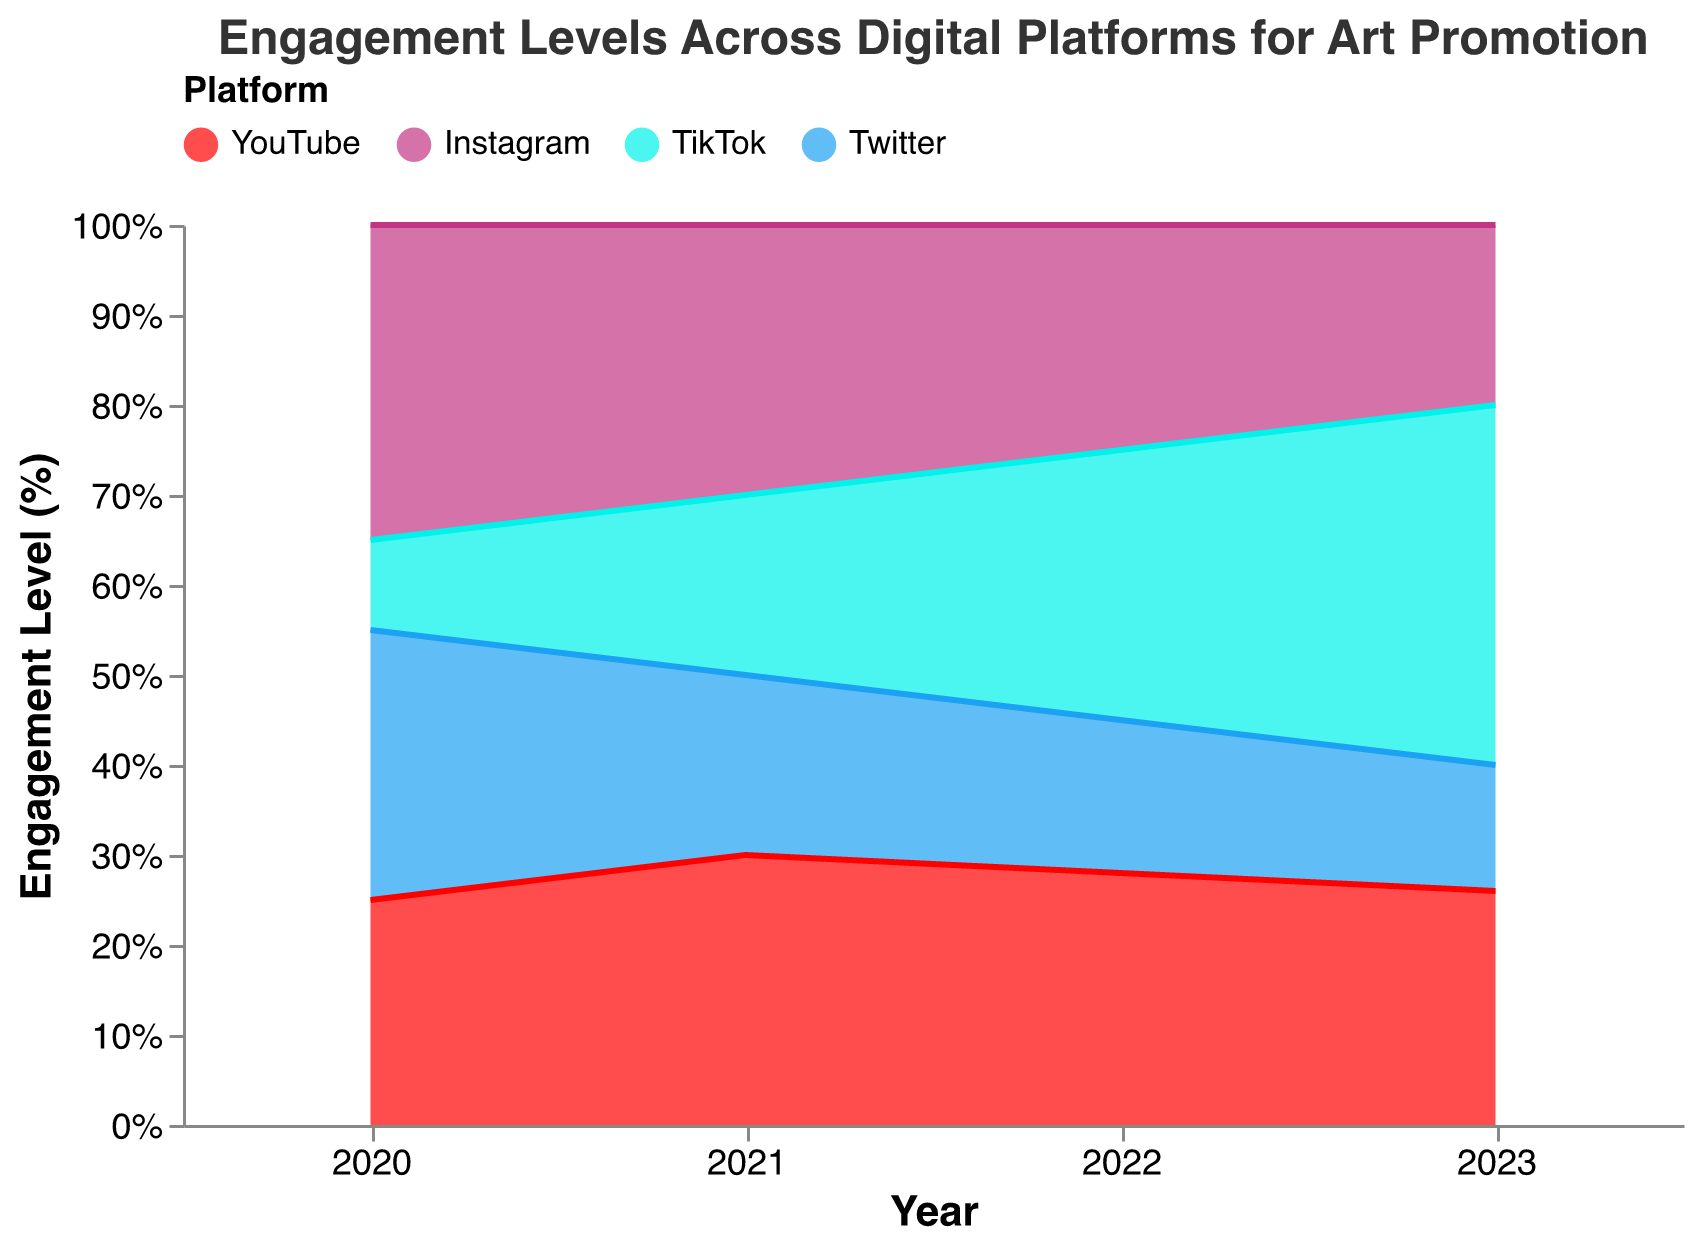What is the title of the chart? The title of the chart is displayed at the top and usually summarizes what the chart is about.
Answer: Engagement Levels Across Digital Platforms for Art Promotion Which year shows the highest engagement level for TikTok? By observing the chart, TikTok's engagement level is highest in 2023 as it occupies the largest area on the graph in that year.
Answer: 2023 Which platform had the highest engagement level in 2020? By visually inspecting the stack for the year 2020, Instagram shows the highest engagement level as it covers the largest portion of the stack.
Answer: Instagram Compare the engagement levels of YouTube and Instagram in 2021. Which had a higher engagement level? By comparing the two platforms in 2021 on the 100% stacked area chart, we see that YouTube and Instagram each occupy an equal area for the year 2021.
Answer: Equal Calculate the combined engagement level of TikTok and Twitter in 2022. In 2022, TikTok had a 30% engagement level and Twitter had 17%. Summing these values gives 30% + 17% = 47%.
Answer: 47% Analyze the trend in engagement levels for Twitter from 2020 to 2023. What pattern do you observe? By observing the chart, the engagement level for Twitter shows a declining trend from 2020 (30%) to 2023 (14%).
Answer: Declining Which platform showed the most significant increase in engagement levels from 2020 to 2023? By comparing the areas across the years, TikTok shows the most significant increase, going from 10% in 2020 to 40% in 2023.
Answer: TikTok What was the engagement level of Instagram in 2023 compared to 2020? The engagement level for Instagram decreased from 35% in 2020 to 20% in 2023.
Answer: Decreased Identify the platform with the lowest engagement level in 2021. By observing the stack for the year 2021, Twitter has the smallest area, indicating the lowest engagement level of the platforms.
Answer: Twitter Evaluate the change in YouTube's engagement level from 2021 to 2022. YouTube's engagement level decreased from 30% in 2021 to 28% in 2022.
Answer: Decreased 